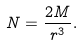<formula> <loc_0><loc_0><loc_500><loc_500>N = \frac { 2 M } { r ^ { 3 } } .</formula> 